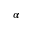<formula> <loc_0><loc_0><loc_500><loc_500>\alpha</formula> 